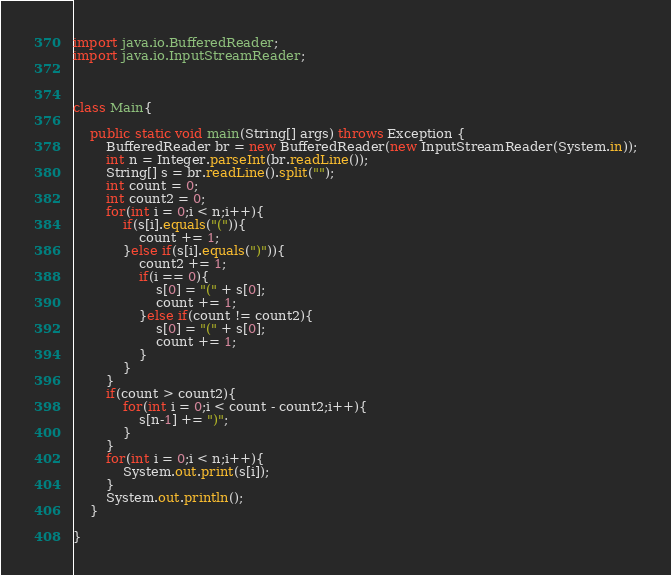<code> <loc_0><loc_0><loc_500><loc_500><_Java_>import java.io.BufferedReader;
import java.io.InputStreamReader;



class Main{

	public static void main(String[] args) throws Exception {
		BufferedReader br = new BufferedReader(new InputStreamReader(System.in));
		int n = Integer.parseInt(br.readLine());
		String[] s = br.readLine().split("");
		int count = 0;
		int count2 = 0;
		for(int i = 0;i < n;i++){
			if(s[i].equals("(")){
				count += 1;
			}else if(s[i].equals(")")){
				count2 += 1;
				if(i == 0){
					s[0] = "(" + s[0];
					count += 1;
				}else if(count != count2){
					s[0] = "(" + s[0];
					count += 1;
				}
			}
		}
		if(count > count2){
			for(int i = 0;i < count - count2;i++){
				s[n-1] += ")";
			}
		}
		for(int i = 0;i < n;i++){
			System.out.print(s[i]);
		}
		System.out.println();
	}

}
</code> 